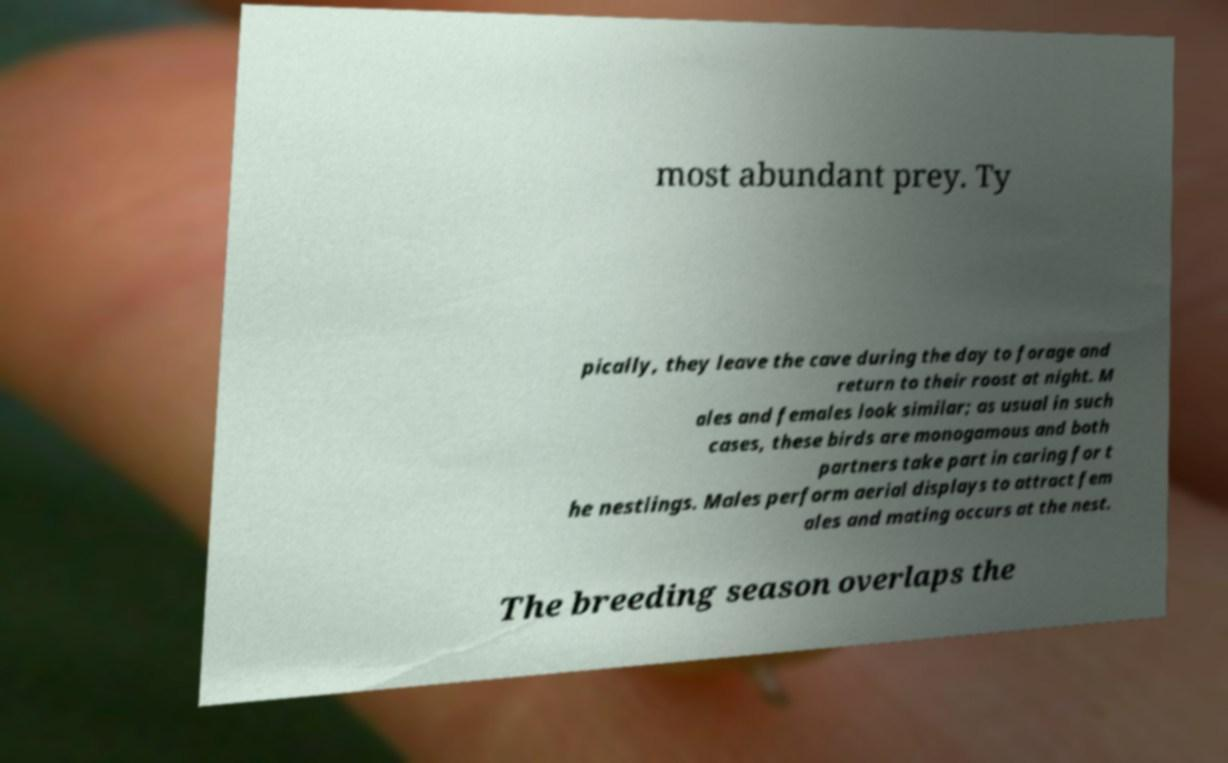For documentation purposes, I need the text within this image transcribed. Could you provide that? most abundant prey. Ty pically, they leave the cave during the day to forage and return to their roost at night. M ales and females look similar; as usual in such cases, these birds are monogamous and both partners take part in caring for t he nestlings. Males perform aerial displays to attract fem ales and mating occurs at the nest. The breeding season overlaps the 